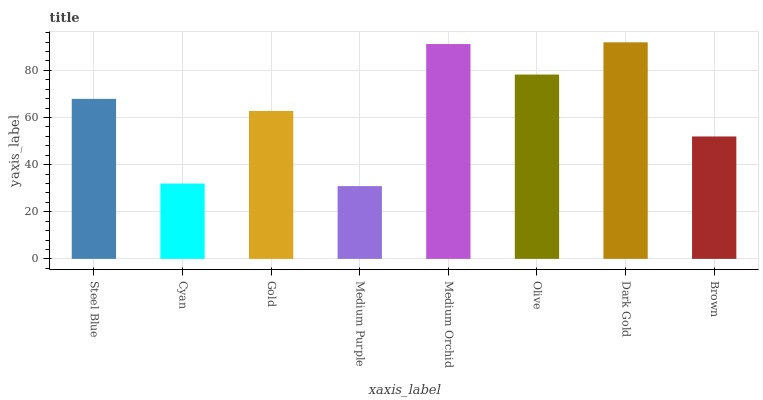Is Medium Purple the minimum?
Answer yes or no. Yes. Is Dark Gold the maximum?
Answer yes or no. Yes. Is Cyan the minimum?
Answer yes or no. No. Is Cyan the maximum?
Answer yes or no. No. Is Steel Blue greater than Cyan?
Answer yes or no. Yes. Is Cyan less than Steel Blue?
Answer yes or no. Yes. Is Cyan greater than Steel Blue?
Answer yes or no. No. Is Steel Blue less than Cyan?
Answer yes or no. No. Is Steel Blue the high median?
Answer yes or no. Yes. Is Gold the low median?
Answer yes or no. Yes. Is Cyan the high median?
Answer yes or no. No. Is Dark Gold the low median?
Answer yes or no. No. 